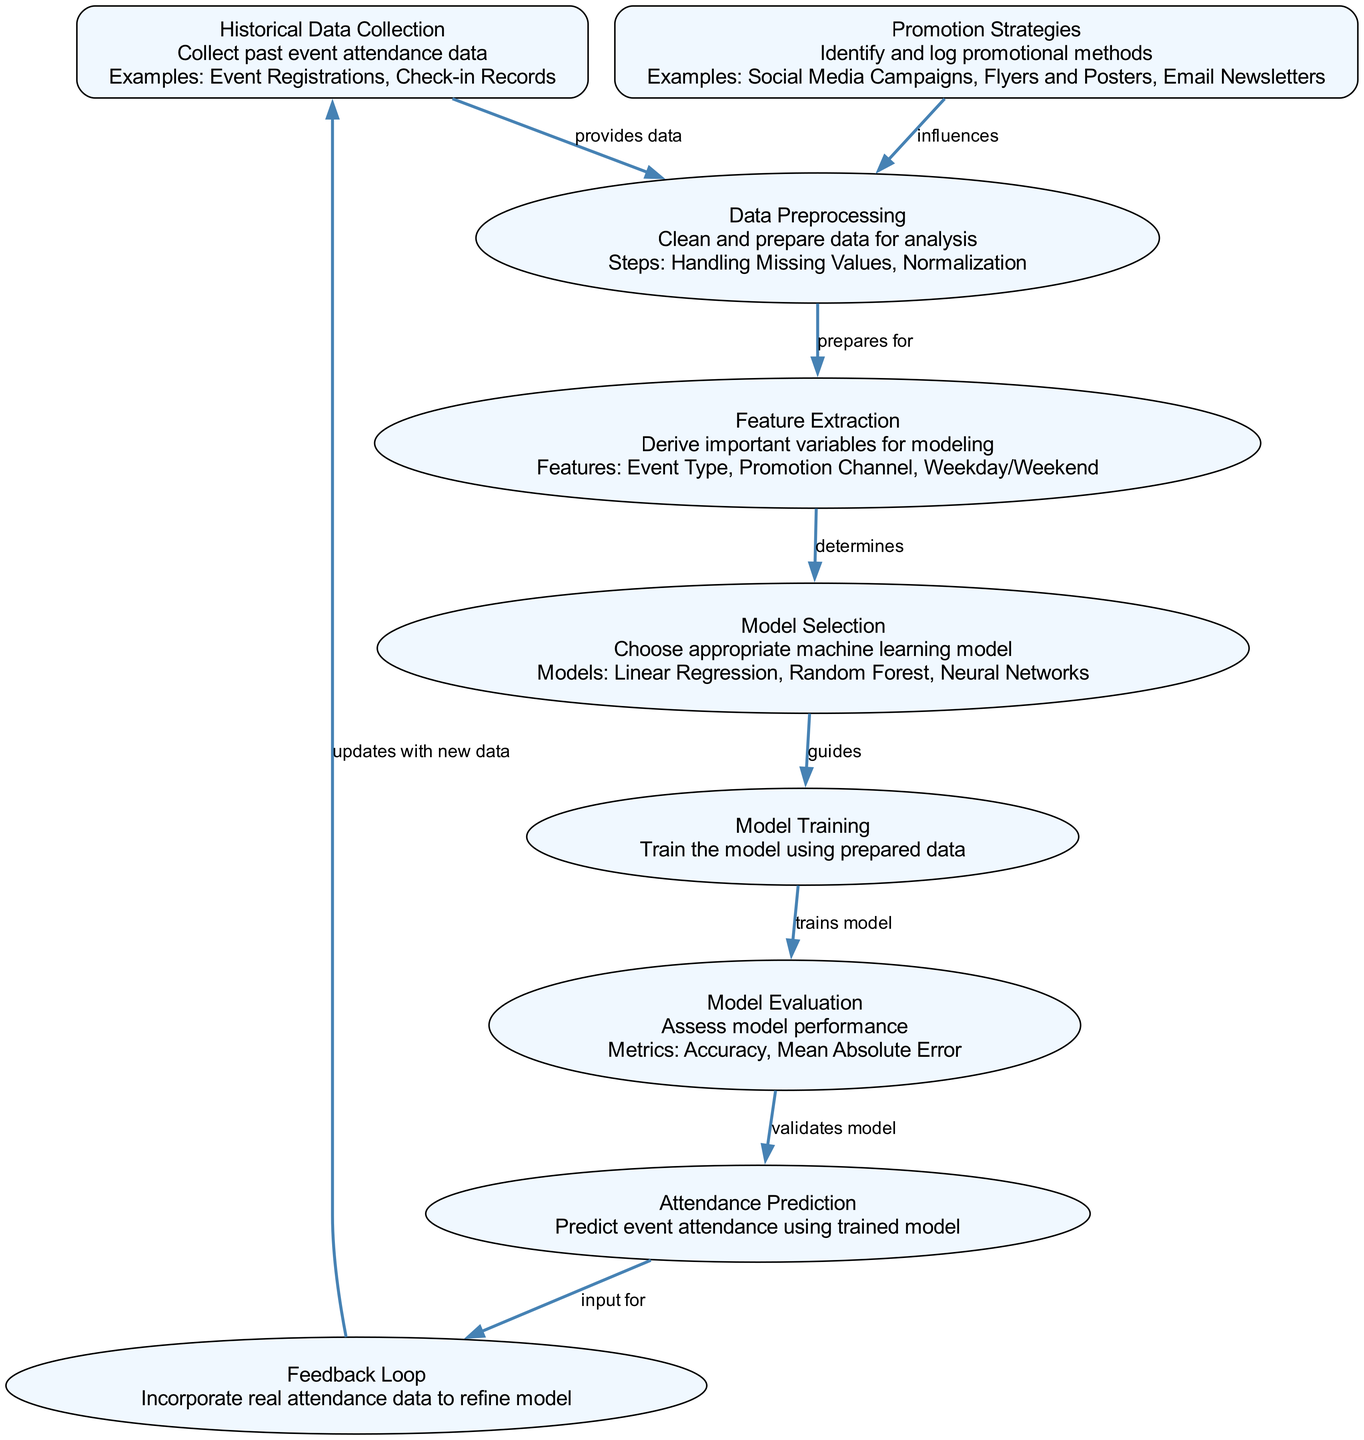What is the first node in the diagram? The first node is "Historical Data Collection," which is located at the top of the diagram.
Answer: Historical Data Collection How many nodes are present in the diagram? The diagram contains a total of nine nodes, as identified in the provided data.
Answer: Nine What is the last step before prediction? The last step before prediction is "Model Evaluation," which validates the model's performance.
Answer: Model Evaluation Which node provides data to data preprocessing? The node "Historical Data Collection" provides data to the "Data Preprocessing" node.
Answer: Historical Data Collection What influences the data preprocessing stage? The "Promotion Strategies" node influences the data preprocessing stage by logging promotional methods.
Answer: Promotion Strategies Which type of model can be selected during the model selection process? One of the types of models that can be selected is "Random Forest," as listed in the example models.
Answer: Random Forest How does the feedback loop update the historical data collection? The feedback loop updates the historical data collection by incorporating real attendance data to refine the model.
Answer: Incorporating real attendance data What metrics are used to evaluate the model? The metrics used to evaluate the model include "Accuracy" and "Mean Absolute Error," which measure the model's performance.
Answer: Accuracy, Mean Absolute Error What does feature extraction determine for model selection? Feature extraction determines the important features for modeling such as "Event Type," "Promotion Channel," and "Weekday/Weekend."
Answer: Event Type, Promotion Channel, Weekday/Weekend 